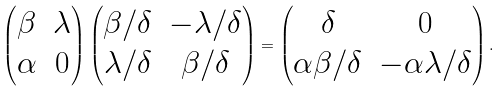<formula> <loc_0><loc_0><loc_500><loc_500>\left ( \begin{matrix} \beta & \lambda \\ \alpha & 0 \end{matrix} \right ) \left ( \begin{matrix} \beta / \delta & - \lambda / \delta \\ \lambda / \delta & \beta / \delta \end{matrix} \right ) = \left ( \begin{matrix} \delta & 0 \\ \alpha \beta / \delta & - \alpha \lambda / \delta \end{matrix} \right ) .</formula> 